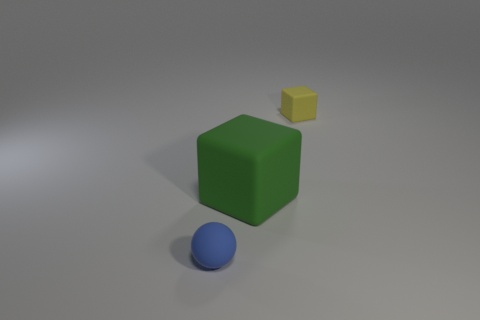Do the tiny cube and the tiny rubber ball have the same color?
Give a very brief answer. No. What is the size of the green matte cube?
Offer a terse response. Large. Is there a small blue matte sphere that is on the right side of the tiny rubber thing that is to the left of the tiny object that is behind the tiny blue matte sphere?
Your answer should be compact. No. What shape is the other object that is the same size as the blue thing?
Your answer should be compact. Cube. How many large things are green metallic objects or yellow blocks?
Your answer should be compact. 0. What color is the big cube that is the same material as the small blue sphere?
Ensure brevity in your answer.  Green. Is the shape of the tiny thing that is on the left side of the small rubber cube the same as the tiny object to the right of the small blue thing?
Provide a succinct answer. No. What number of rubber objects are large blocks or purple cylinders?
Ensure brevity in your answer.  1. Is there any other thing that is the same shape as the green thing?
Offer a terse response. Yes. What material is the tiny object that is right of the blue matte object?
Your response must be concise. Rubber. 